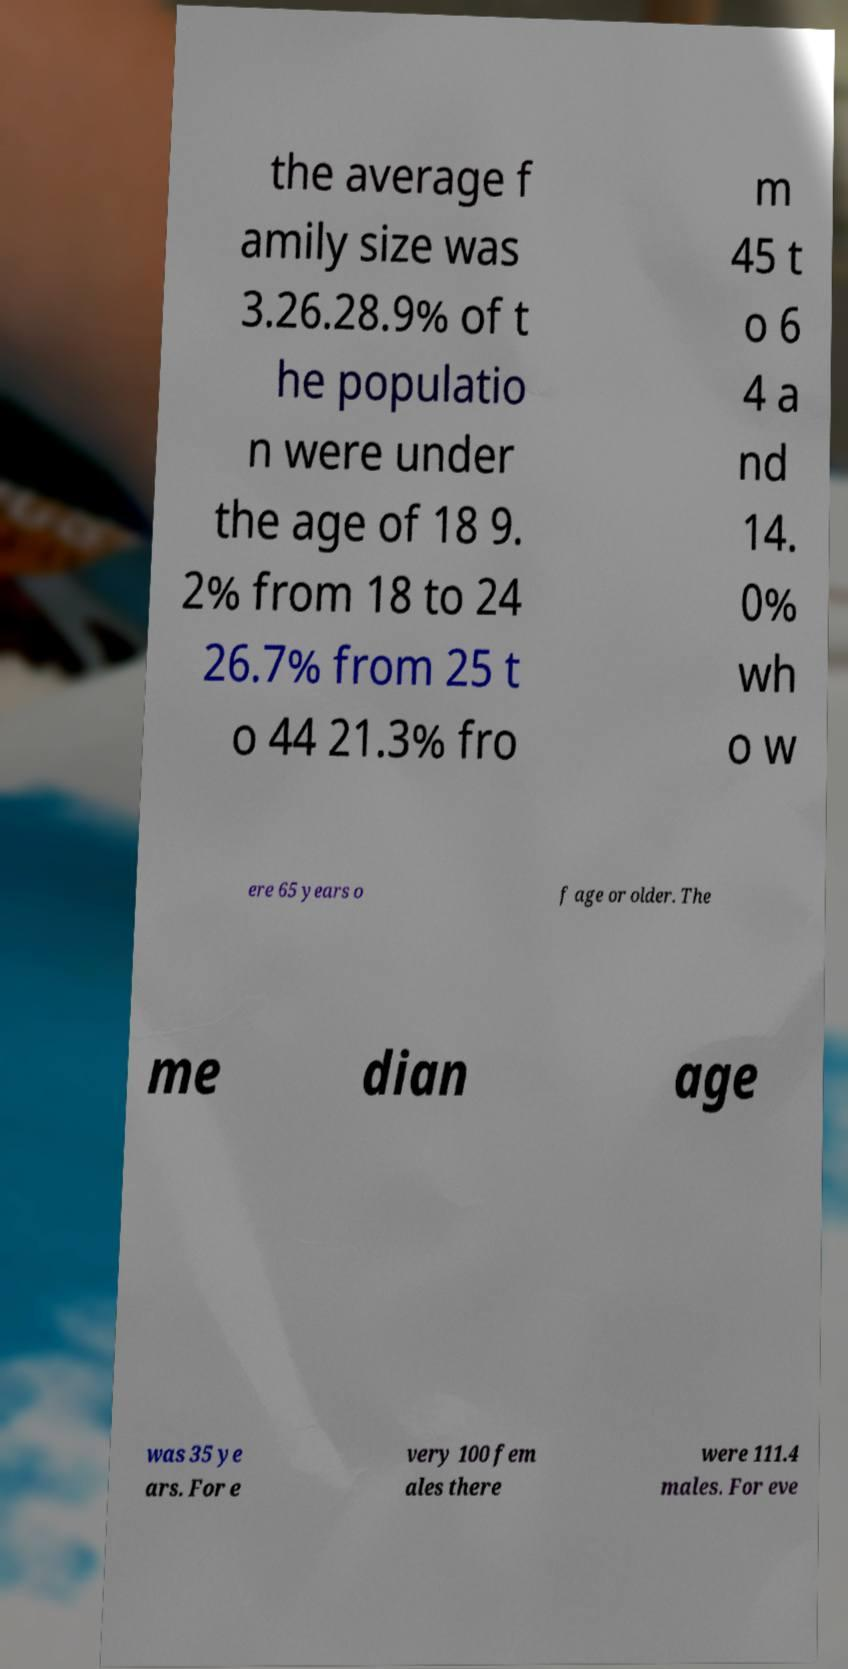Could you extract and type out the text from this image? the average f amily size was 3.26.28.9% of t he populatio n were under the age of 18 9. 2% from 18 to 24 26.7% from 25 t o 44 21.3% fro m 45 t o 6 4 a nd 14. 0% wh o w ere 65 years o f age or older. The me dian age was 35 ye ars. For e very 100 fem ales there were 111.4 males. For eve 